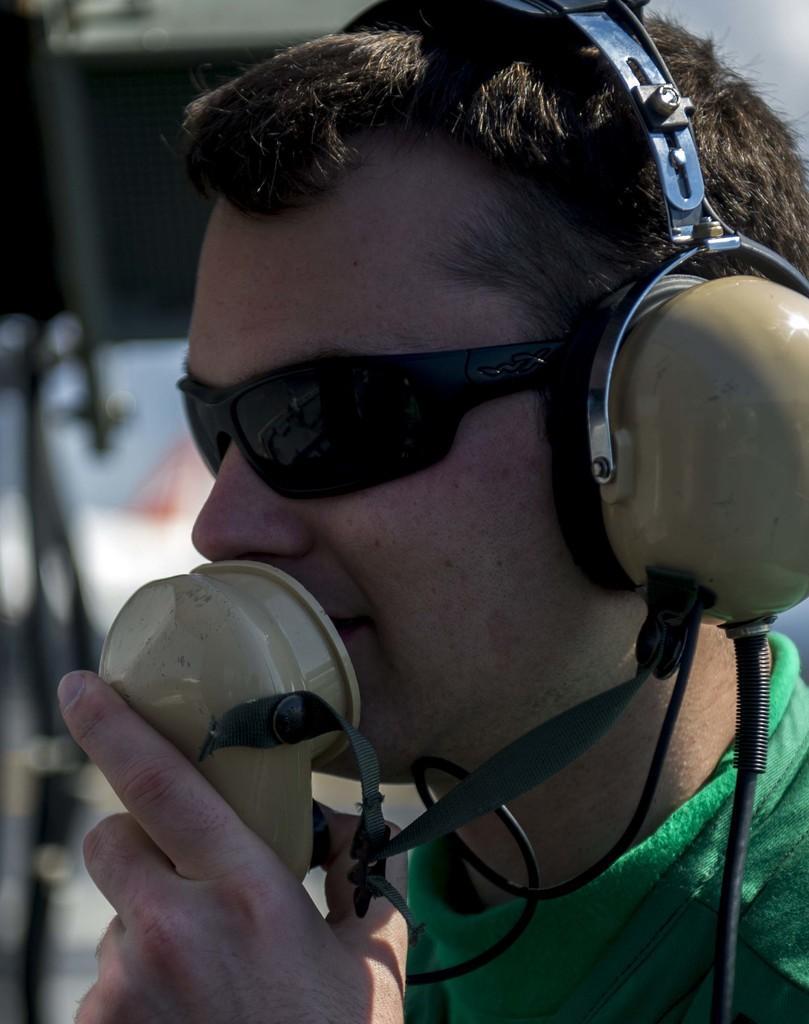How would you summarize this image in a sentence or two? A man is speaking in the microphone, he wore headset, spectacles, t-shirt. 